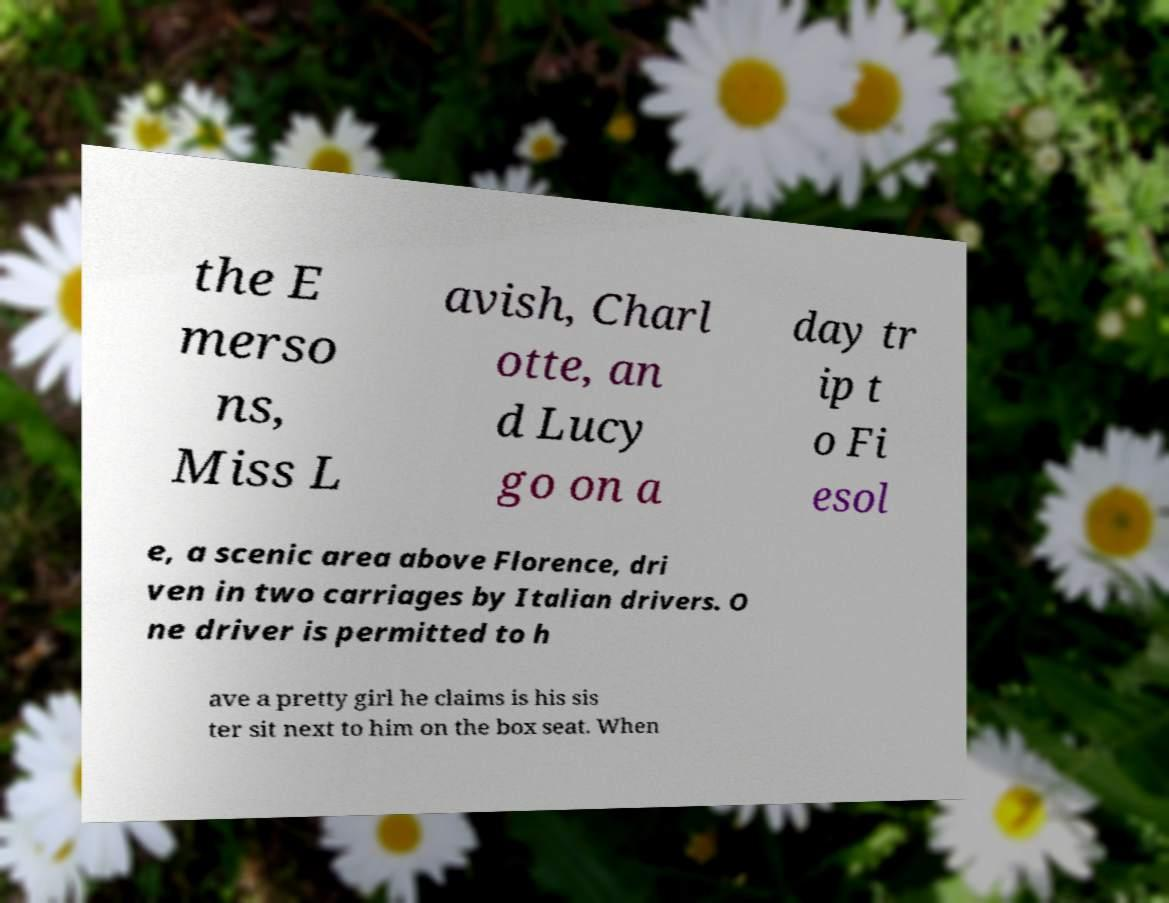Please read and relay the text visible in this image. What does it say? the E merso ns, Miss L avish, Charl otte, an d Lucy go on a day tr ip t o Fi esol e, a scenic area above Florence, dri ven in two carriages by Italian drivers. O ne driver is permitted to h ave a pretty girl he claims is his sis ter sit next to him on the box seat. When 